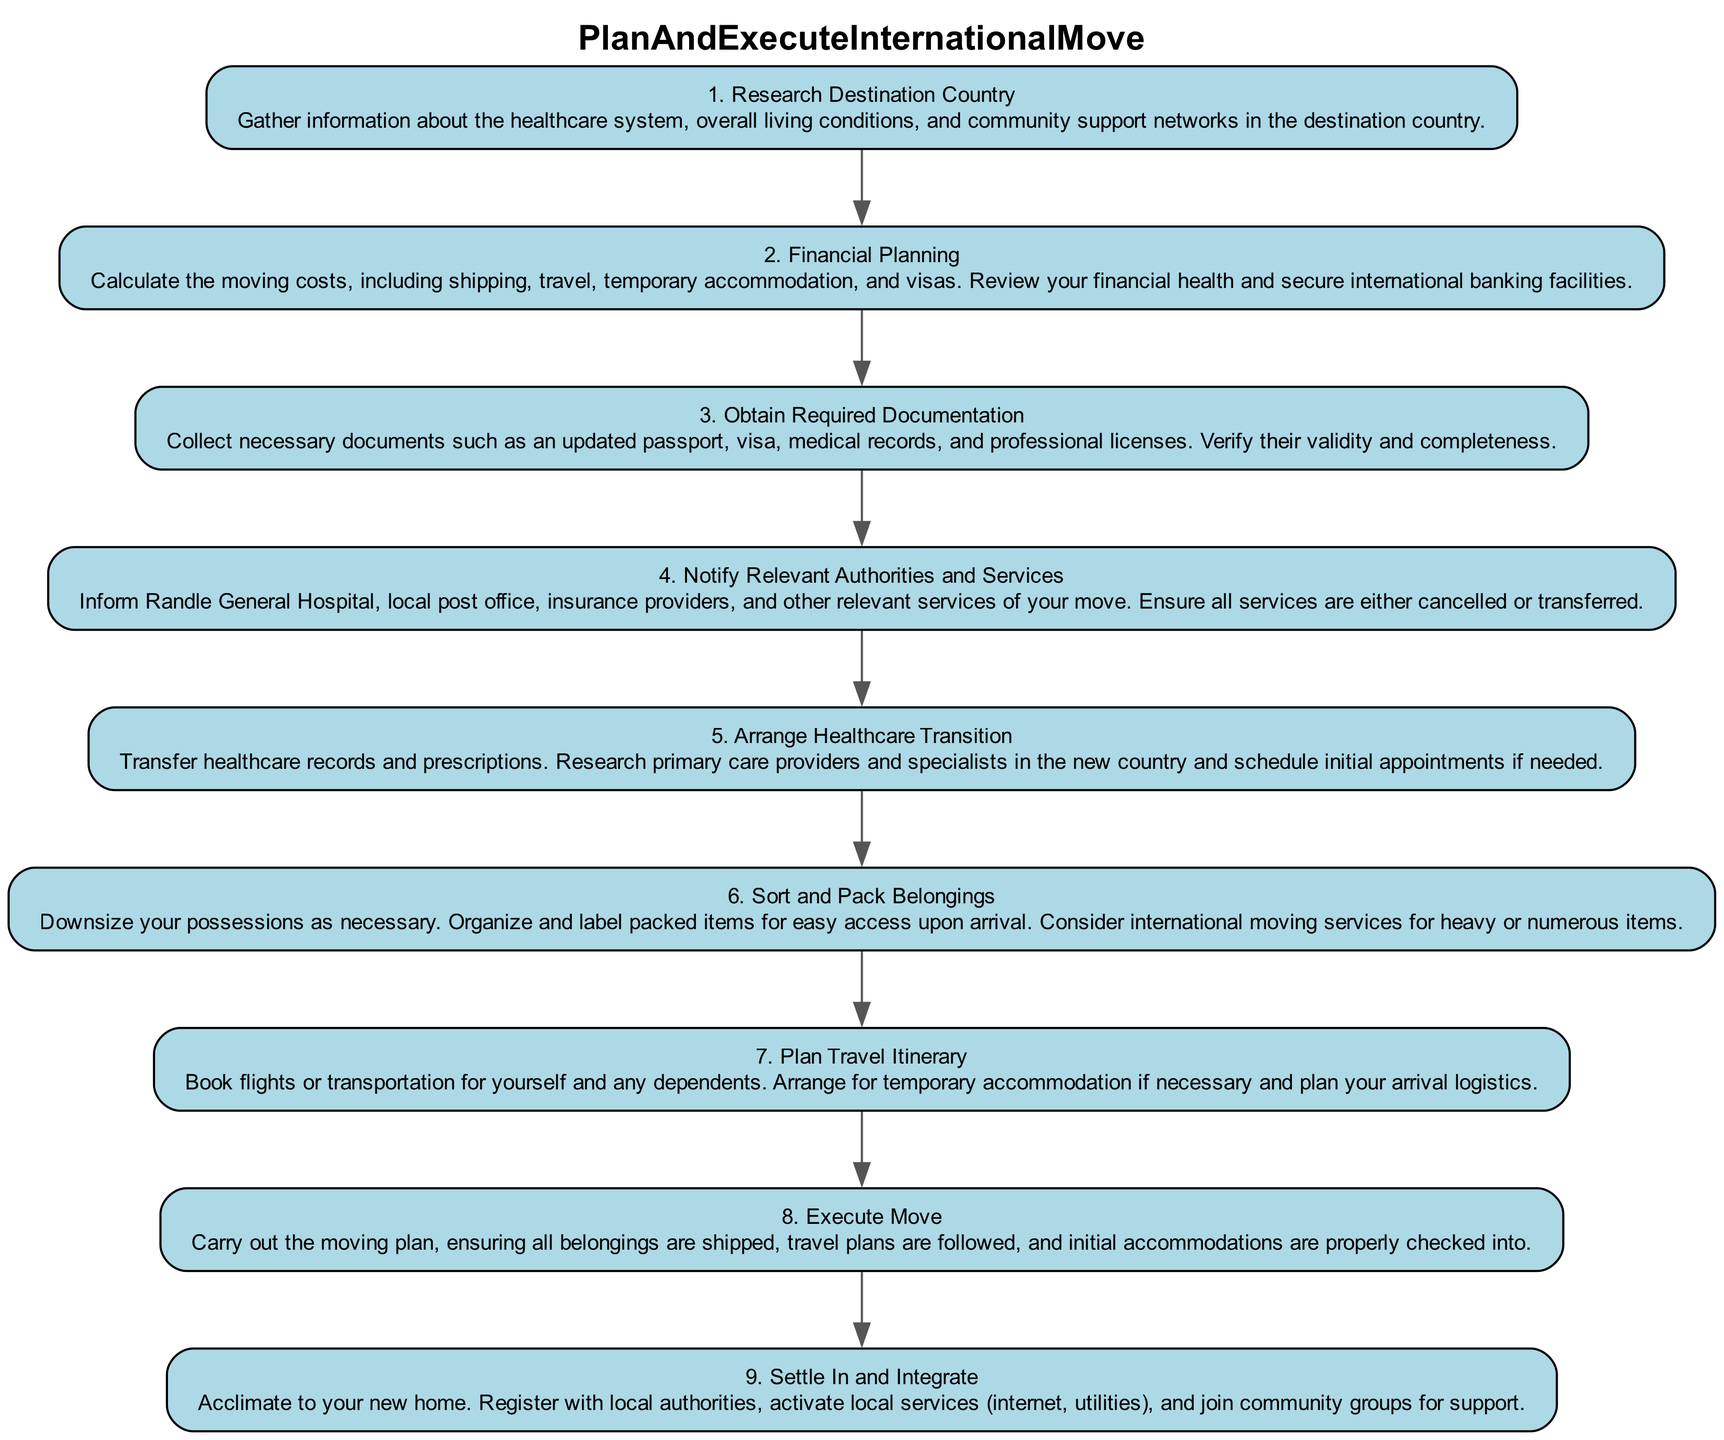What is the first step in the international move plan? The first step in the diagram is labeled as "1. Research Destination Country," which is the starting point of the process.
Answer: Research Destination Country How many nodes are in the diagram? The diagram contains nine nodes, each representing a step in the international move plan, labeled from 1 to 9.
Answer: 9 Which step involves financial calculations? Step 2 is labeled "2. Financial Planning," which specifically mentions calculating moving costs as a primary activity.
Answer: Financial Planning What is the last step of the plan? The last node in the diagram is labeled "9. Settle In and Integrate," which signifies the final process of acclimating to the new environment.
Answer: Settle In and Integrate What steps are directly connected to the "Obtain Required Documentation" step? "Obtain Required Documentation," or Step 3, has edges from Step 2 (Financial Planning) and leads to Step 4 (Notify Relevant Authorities and Services), indicating a flow in the process.
Answer: Financial Planning, Notify Relevant Authorities and Services Which steps focus on healthcare? Steps 1, 5, and 9 are relevant to healthcare: Step 1 is about researching the healthcare system, Step 5 involves arranging healthcare transition, and Step 9 is about settling in and registering with local authorities for healthcare services.
Answer: Research Destination Country, Arrange Healthcare Transition, Settle In and Integrate What do you do in Step 6? Step 6 is labeled "6. Sort and Pack Belongings," which entails downsizing possessions and organizing packed items for easy access.
Answer: Sort and Pack Belongings What step comes after notifying relevant authorities? Following Step 4 ("Notify Relevant Authorities and Services"), the next step is Step 5 ("Arrange Healthcare Transition"), indicating a sequence in the international moving process.
Answer: Arrange Healthcare Transition What is necessary to secure for financial planning? The diagram specifically mentions in Step 2 ("Financial Planning") to secure international banking facilities as part of the moving cost calculations.
Answer: International banking facilities 